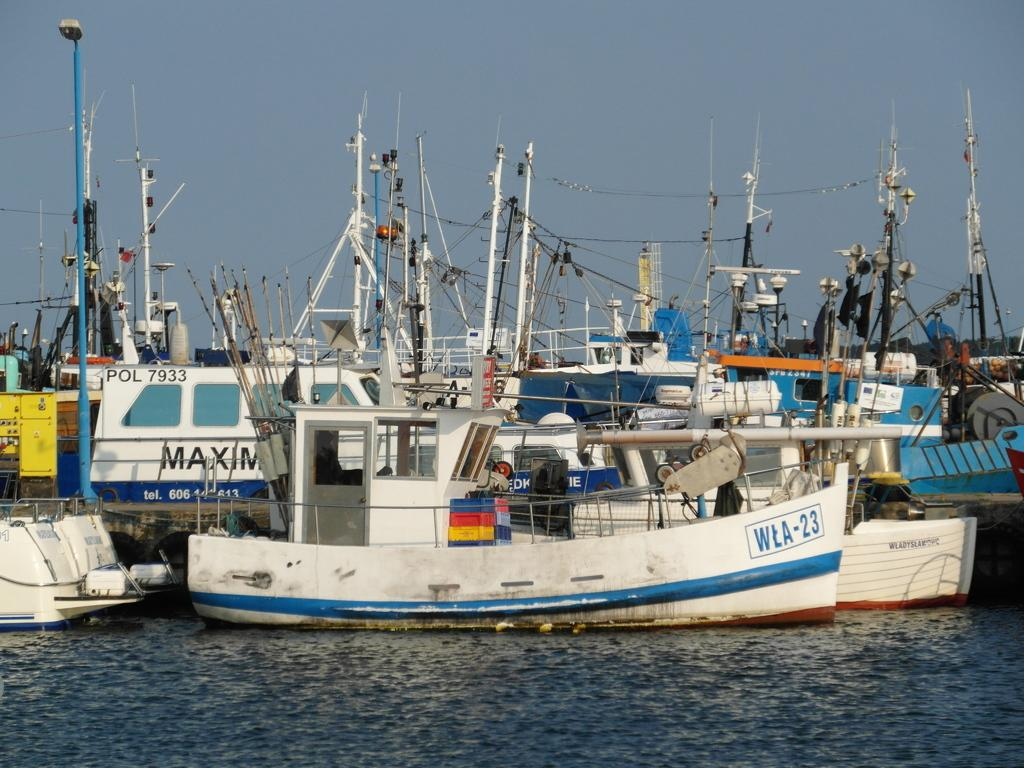What type of vehicles are in the water in the image? There are boats in the water in the image. What type of lighting is present in the image? There are pole lights in the image. What is the condition of the sky in the image? The sky is cloudy in the image. What religious symbol can be seen on the boats in the image? There is no religious symbol present on the boats in the image. How many servants are visible in the image? There are no servants present in the image. 